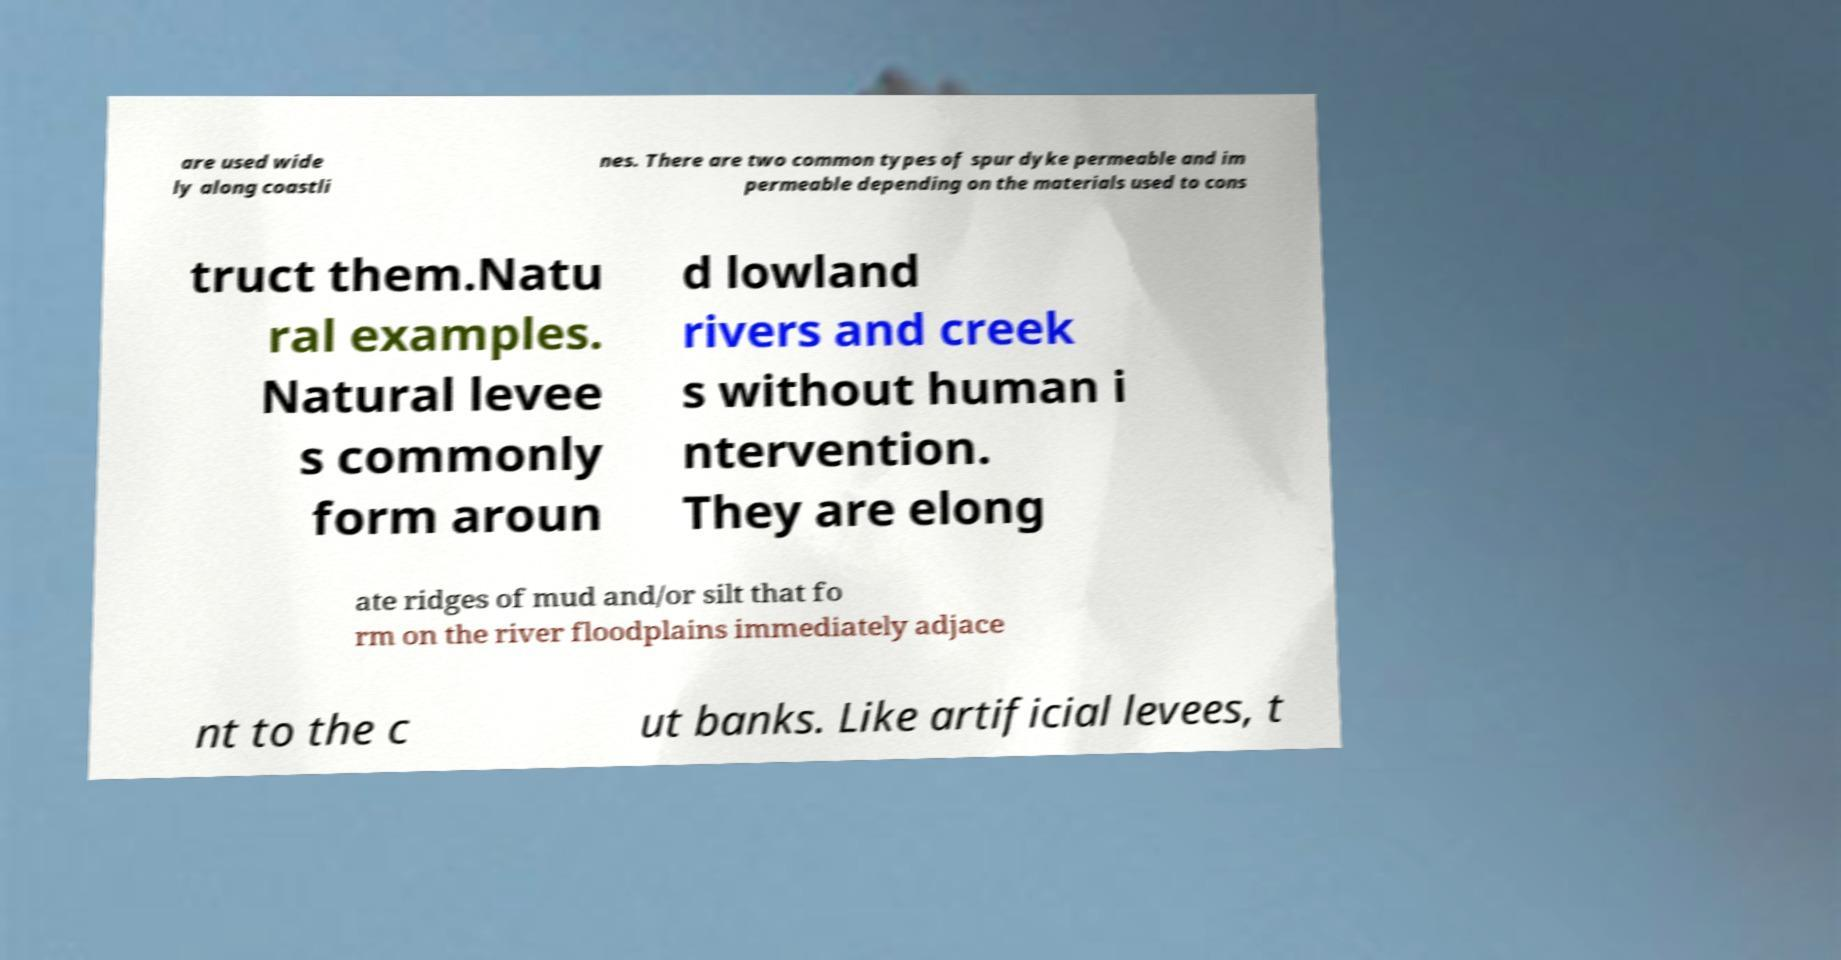Could you extract and type out the text from this image? are used wide ly along coastli nes. There are two common types of spur dyke permeable and im permeable depending on the materials used to cons truct them.Natu ral examples. Natural levee s commonly form aroun d lowland rivers and creek s without human i ntervention. They are elong ate ridges of mud and/or silt that fo rm on the river floodplains immediately adjace nt to the c ut banks. Like artificial levees, t 